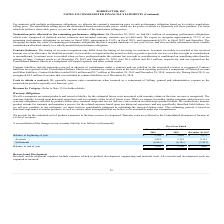According to Formfactor's financial document, What is the basis of warranty liability? based upon historical experience and our estimate of the level of future costs.. The document states: "e revenue is recognized. The warranty liability is based upon historical experience and our estimate of the level of future costs. While we engage in ..." Also, can you calculate: What is the change in Balance at beginning of year from Fiscal Year Ended December 28, 2019 to December 29, 2018? Based on the calculation: 2,102-3,662, the result is -1560 (in thousands). This is based on the information: "Balance at beginning of year $ 2,102 $ 3,662 $ 2,972 Balance at beginning of year $ 2,102 $ 3,662 $ 2,972..." The key data points involved are: 2,102, 3,662. Also, can you calculate: What is the change in Accruals from Fiscal Year Ended December 28, 2019 to December 29, 2018? Based on the calculation: 3,881-3,181, the result is 700 (in thousands). This is based on the information: "Accruals 3,881 3,181 8,115 Accruals 3,881 3,181 8,115..." The key data points involved are: 3,181, 3,881. Additionally, In which year was Accruals less than 4,000 thousands? The document shows two values: 2019 and 2018. Locate and analyze accruals in row 4. From the document: "emaining performance obligations: On December 28, 2019, we had $4.1 million of remaining performance obligations, which were comprised of deferred ser..." Also, What was the Settlements in 2019, 2018 and 2017 respectively? The document contains multiple relevant values: (4,041), (4,741), (7,425) (in thousands). From the document: "Settlements (4,041) (4,741) (7,425) Settlements (4,041) (4,741) (7,425) Settlements (4,041) (4,741) (7,425)..." Also, Where are the warranty costs reflected? Consolidated Statement of Income as a Cost of revenues. The document states: "s recognized. Warranty costs are reflected in the Consolidated Statement of Income as a Cost of revenues...." 